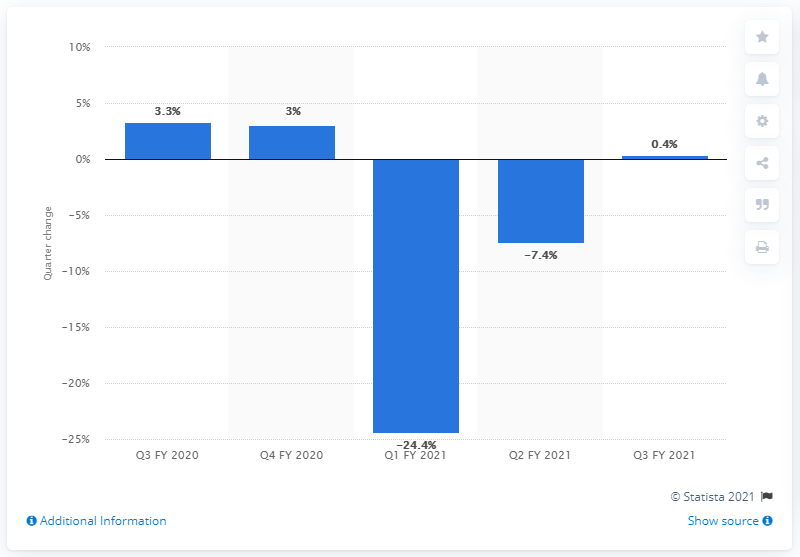List a handful of essential elements in this visual. India's GDP grew by approximately 0.4% in the third quarter of the financial year 2021. 